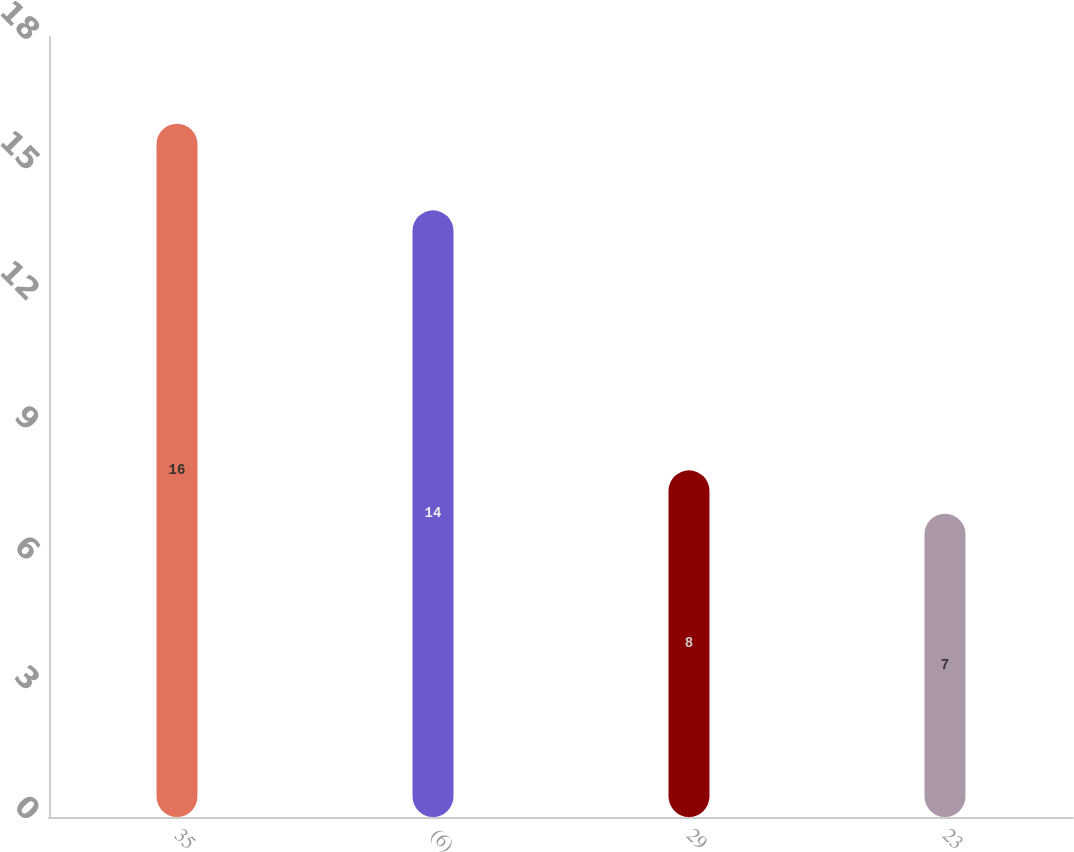Convert chart. <chart><loc_0><loc_0><loc_500><loc_500><bar_chart><fcel>35<fcel>(6)<fcel>29<fcel>23<nl><fcel>16<fcel>14<fcel>8<fcel>7<nl></chart> 